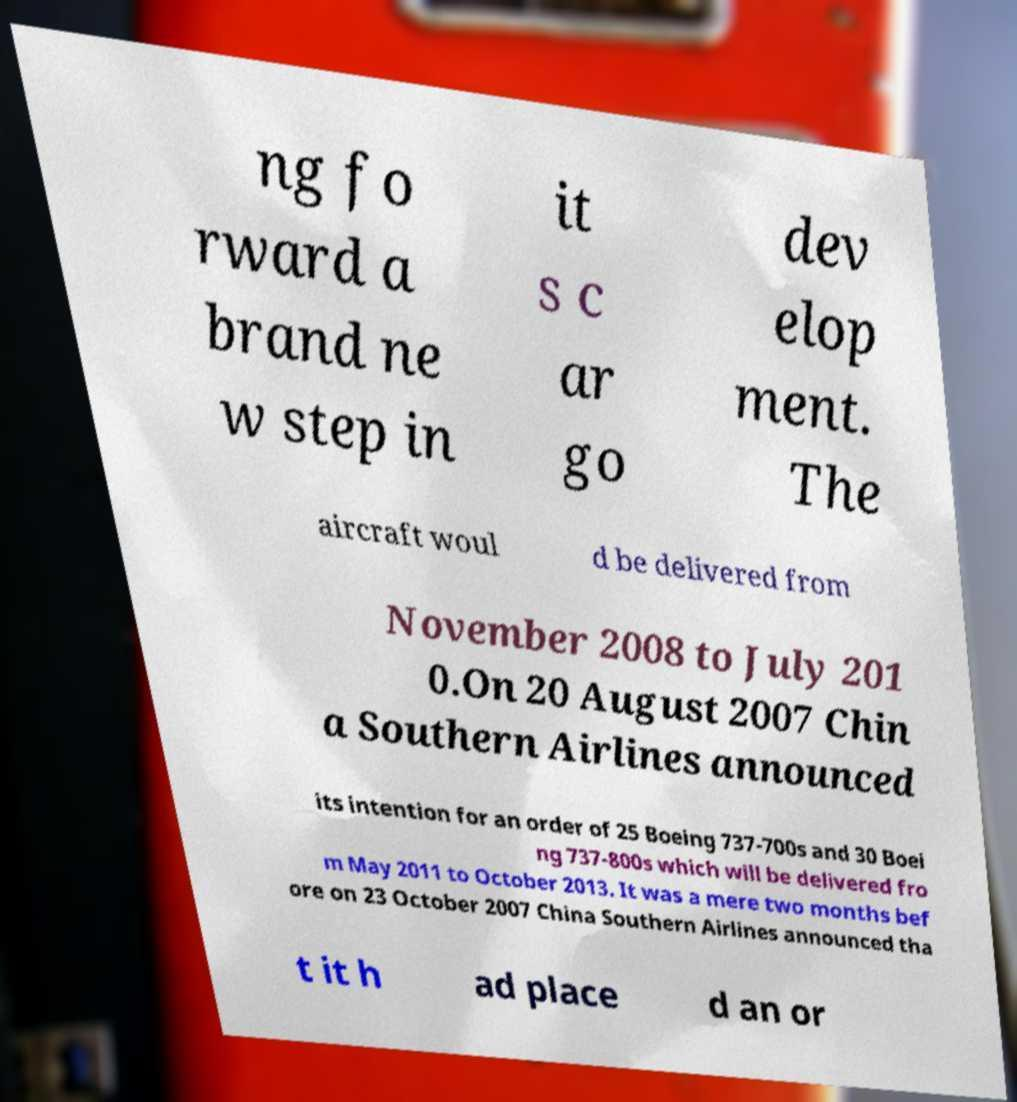What messages or text are displayed in this image? I need them in a readable, typed format. ng fo rward a brand ne w step in it s c ar go dev elop ment. The aircraft woul d be delivered from November 2008 to July 201 0.On 20 August 2007 Chin a Southern Airlines announced its intention for an order of 25 Boeing 737-700s and 30 Boei ng 737-800s which will be delivered fro m May 2011 to October 2013. It was a mere two months bef ore on 23 October 2007 China Southern Airlines announced tha t it h ad place d an or 